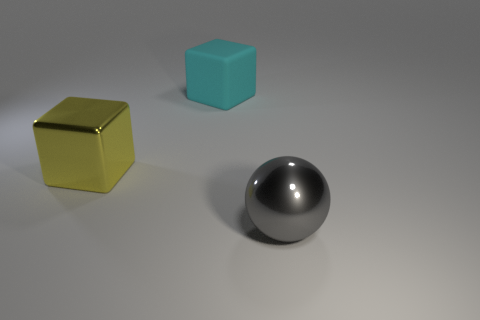Are there any other things that have the same shape as the large gray shiny thing?
Ensure brevity in your answer.  No. What number of rubber cubes are in front of the large matte object?
Your response must be concise. 0. Is there a large block made of the same material as the large ball?
Your answer should be compact. Yes. Are there more large cyan matte blocks behind the big gray object than cyan cubes that are in front of the yellow cube?
Provide a short and direct response. Yes. The gray sphere has what size?
Provide a succinct answer. Large. There is a object on the right side of the cyan matte cube; what shape is it?
Give a very brief answer. Sphere. Do the large yellow metallic thing and the cyan thing have the same shape?
Your response must be concise. Yes. Are there the same number of cyan things left of the matte thing and large yellow rubber balls?
Keep it short and to the point. Yes. What is the shape of the cyan thing?
Provide a short and direct response. Cube. Are there any other things that are the same color as the shiny block?
Offer a terse response. No. 